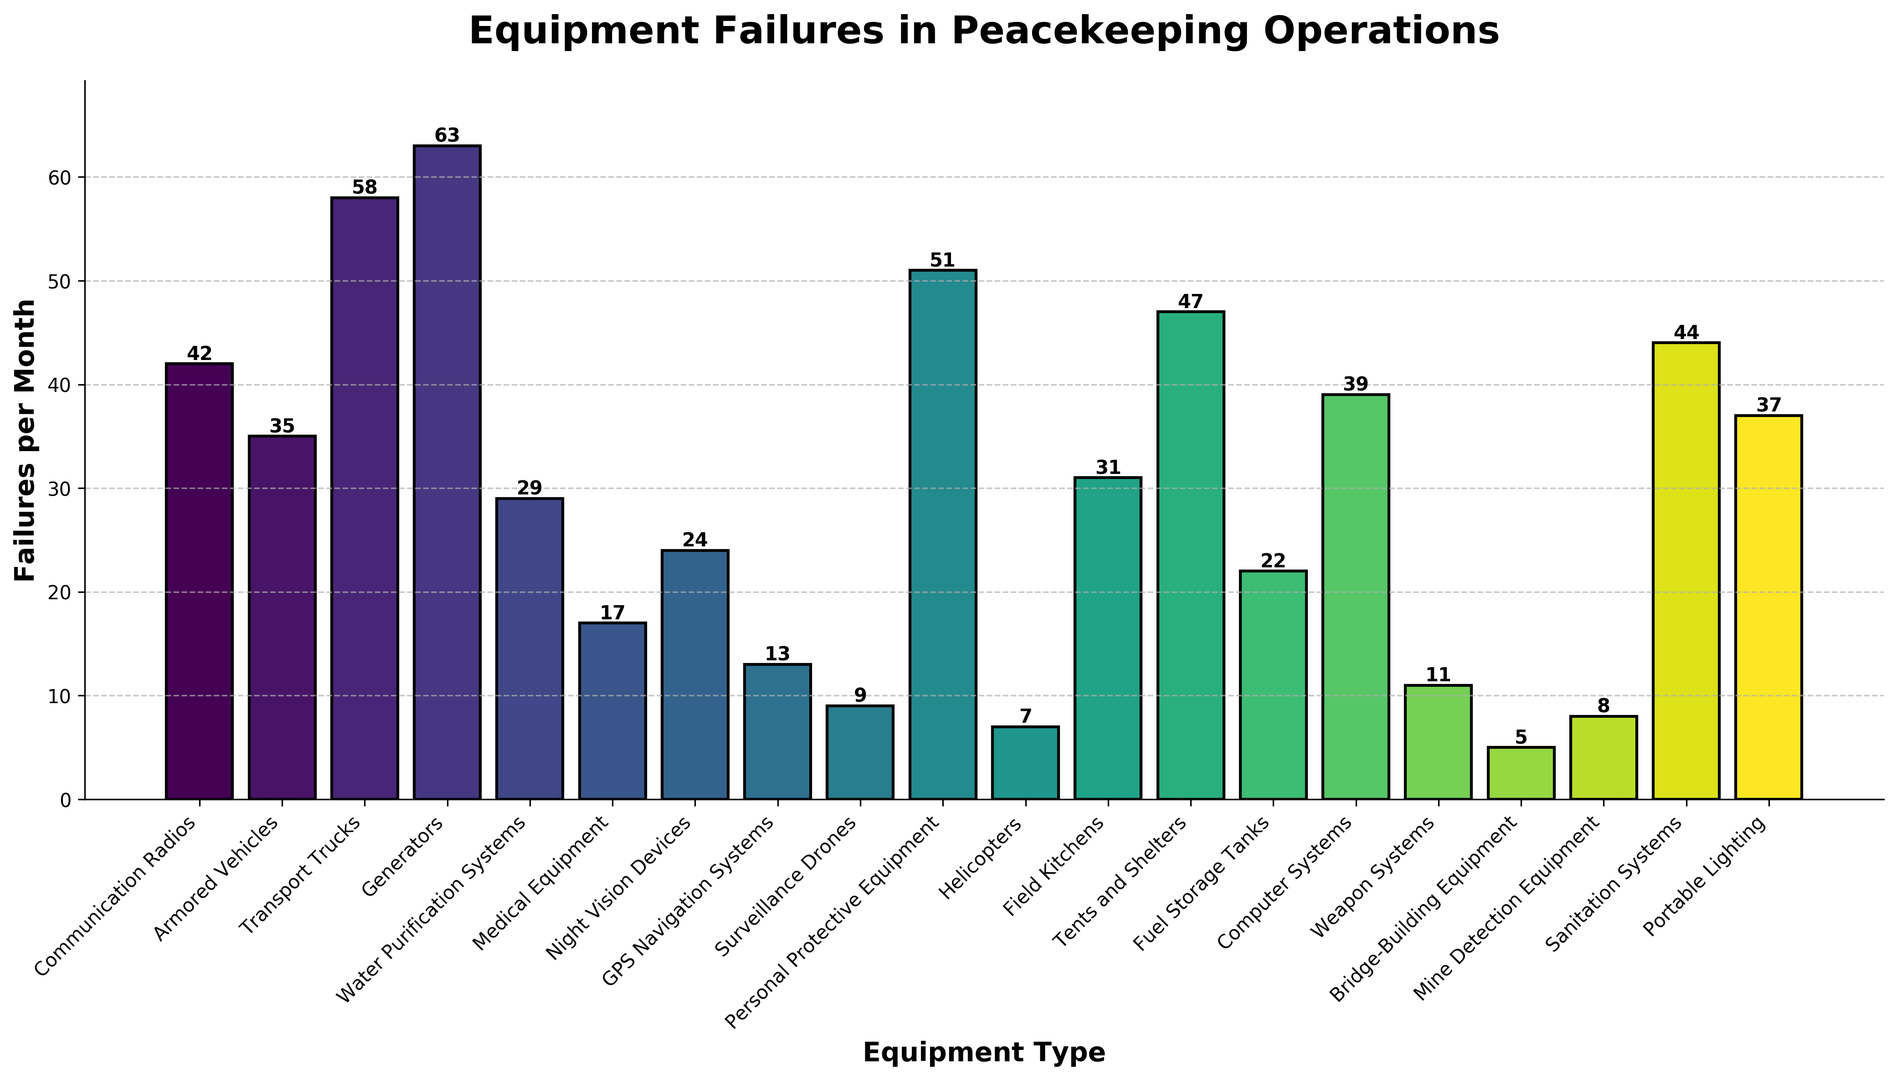What is the most frequently failed equipment type? The tallest bar represents the equipment type with the highest failures per month.
Answer: Generators Which equipment type has fewer failures per month: Communication Radios or Transport Trucks? By comparing the heights of the bars for Communication Radios and Transport Trucks, Communication Radios has a shorter bar.
Answer: Communication Radios How many more failures per month do Personal Protective Equipment have compared to Tents and Shelters? Find the height difference between the bars for Personal Protective Equipment (51) and Tents and Shelters (47): 51 - 47.
Answer: 4 What is the total number of failures per month for Surveillance Drones and GPS Navigation Systems combined? Add the heights of the bars for Surveillance Drones (9) and GPS Navigation Systems (13): 9 + 13.
Answer: 22 What equipment type has the second fewest failures per month? Identify and compare the heights of all bars to find the second shortest bar. The second shortest bar represents Mine Detection Equipment with 8 failures per month.
Answer: Mine Detection Equipment What is the average number of failures per month across all equipment types? Sum all the failures and divide by the total number of equipment types: (42 + 35 + 58 + 63 + 29 + 17 + 24 + 13 + 9 + 51 + 7 + 31 + 47 + 22 + 39 + 11 + 5 + 8 + 44 + 37)/20.
Answer: 30 Which equipment type falls in the middle when ranked by failures per month? Rank all equipment by the height of their bars and find the middle value. With 20 items, the median would be the average of the 10th and 11th values in the sorted list.
Answer: Personal Protective Equipment and Helicopters How many fewer failures per month do Field Kitchens have compared to Generators? Subtract the height of the bar for Field Kitchens (31) from Generators (63): 63 - 31.
Answer: 32 Which equipment type has failures per month closest to the average value of all equipment? Calculate the average of all the failures and find the equipment type whose bar height is closest to this average of 30.
Answer: Communication Radios 